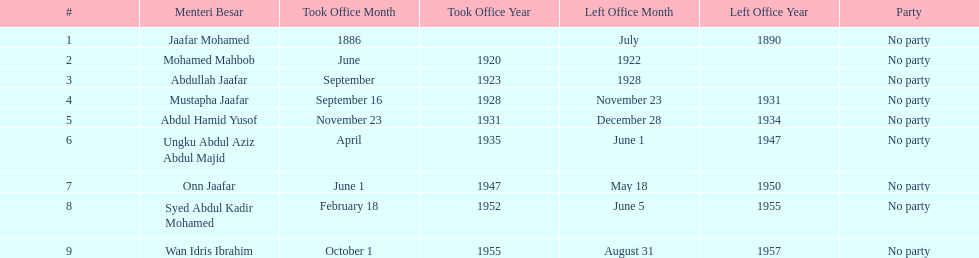Who was in office previous to abdullah jaafar? Mohamed Mahbob. 